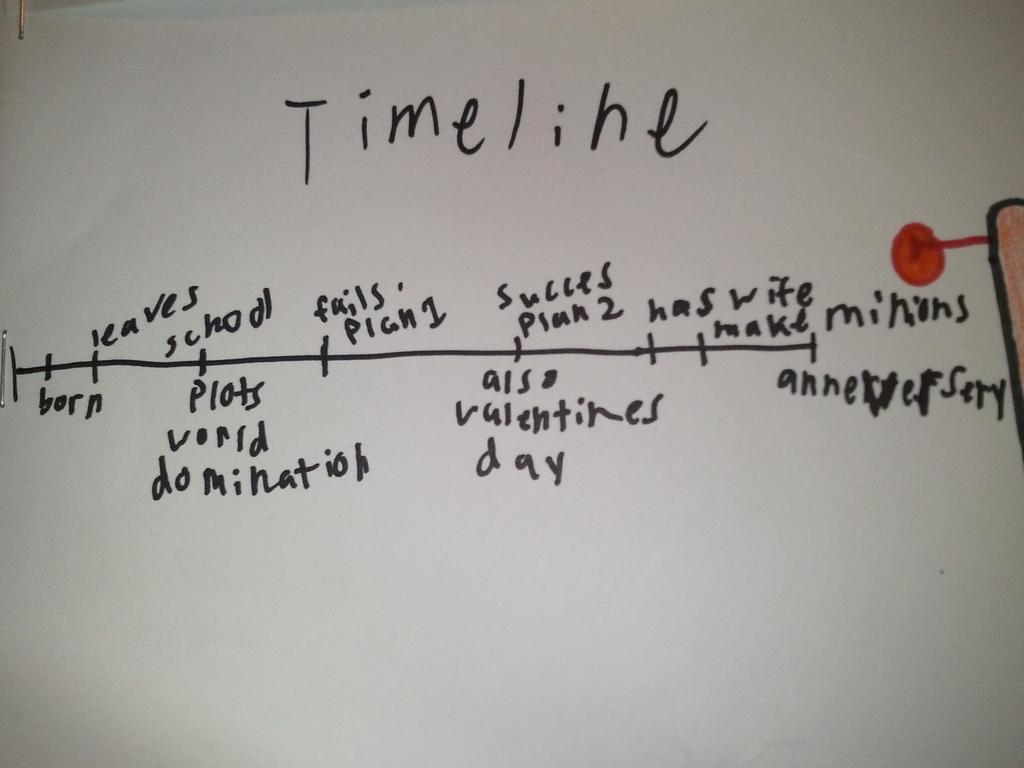<image>
Create a compact narrative representing the image presented. A timeline about world domination and minions is written on a a whiteboard. 